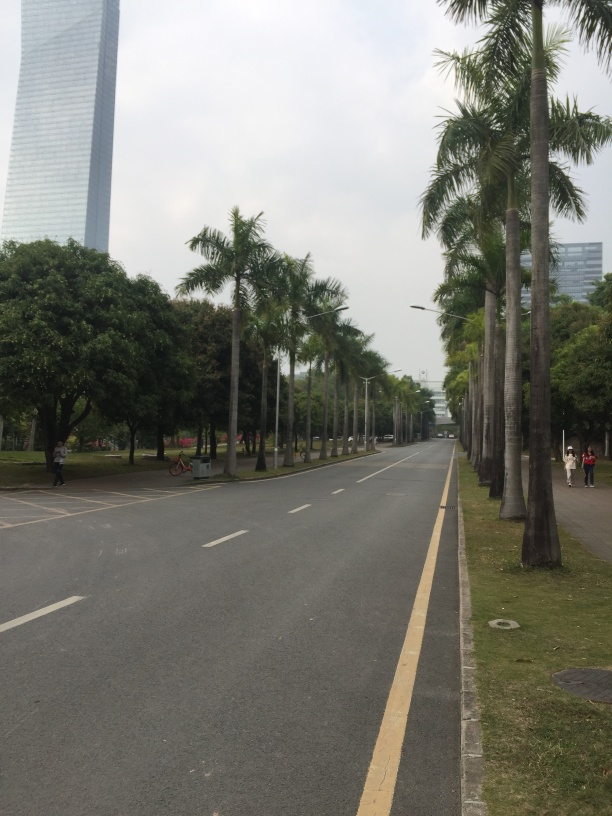Can you describe the weather in this image? The weather appears to be overcast, as indicated by the lack of harsh shadows and the soft, diffused light. There’s no sign of precipitation, and the overall ambience is one of a calm, possibly humid, day. 